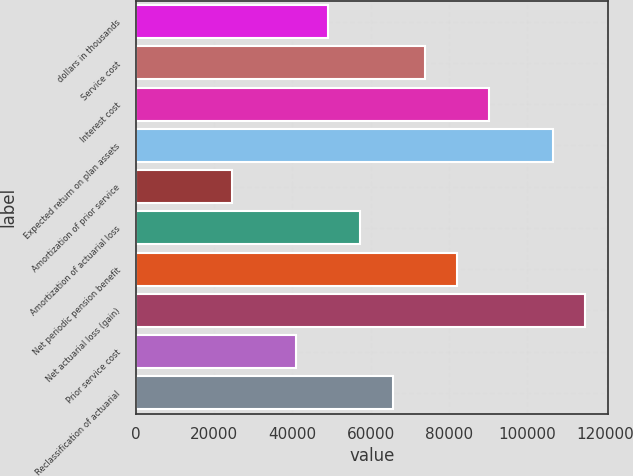Convert chart. <chart><loc_0><loc_0><loc_500><loc_500><bar_chart><fcel>dollars in thousands<fcel>Service cost<fcel>Interest cost<fcel>Expected return on plan assets<fcel>Amortization of prior service<fcel>Amortization of actuarial loss<fcel>Net periodic pension benefit<fcel>Net actuarial loss (gain)<fcel>Prior service cost<fcel>Reclassification of actuarial<nl><fcel>49219.4<fcel>73827.4<fcel>90232.6<fcel>106638<fcel>24611.5<fcel>57422.1<fcel>82030<fcel>114841<fcel>41016.8<fcel>65624.7<nl></chart> 